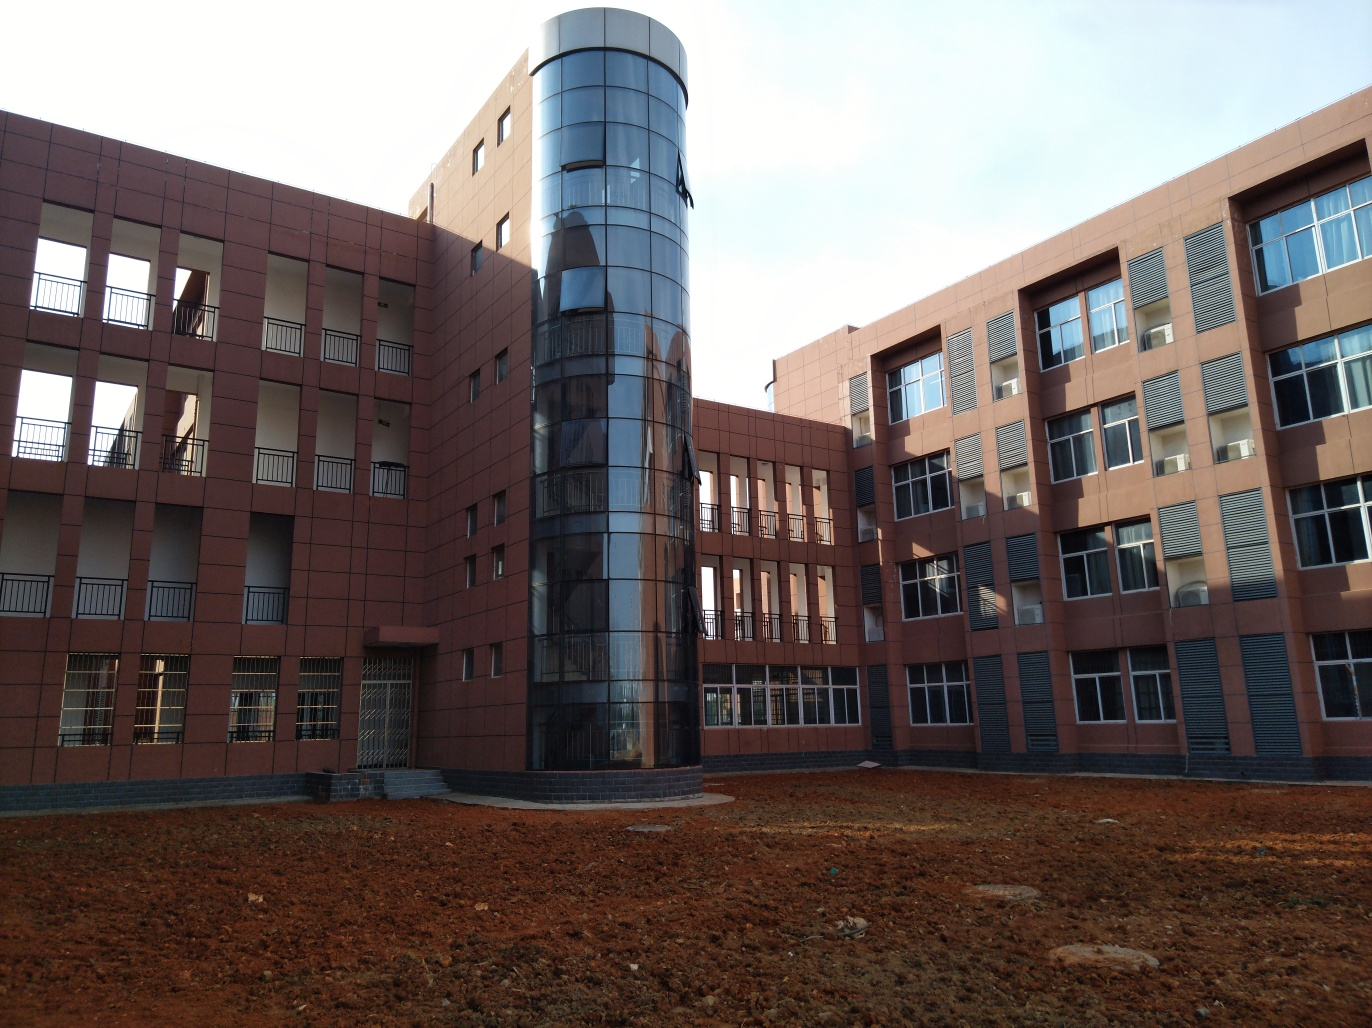Could you tell me about the architectural style of these buildings? The buildings exhibit a modern architectural style with simple geometric forms, a regular pattern of windows, and an absence of ornamental detailing. The use of brick and glass creates a functional and contemporary look, while the round, glass-enclosed structure adds an interesting visual element to the design. 